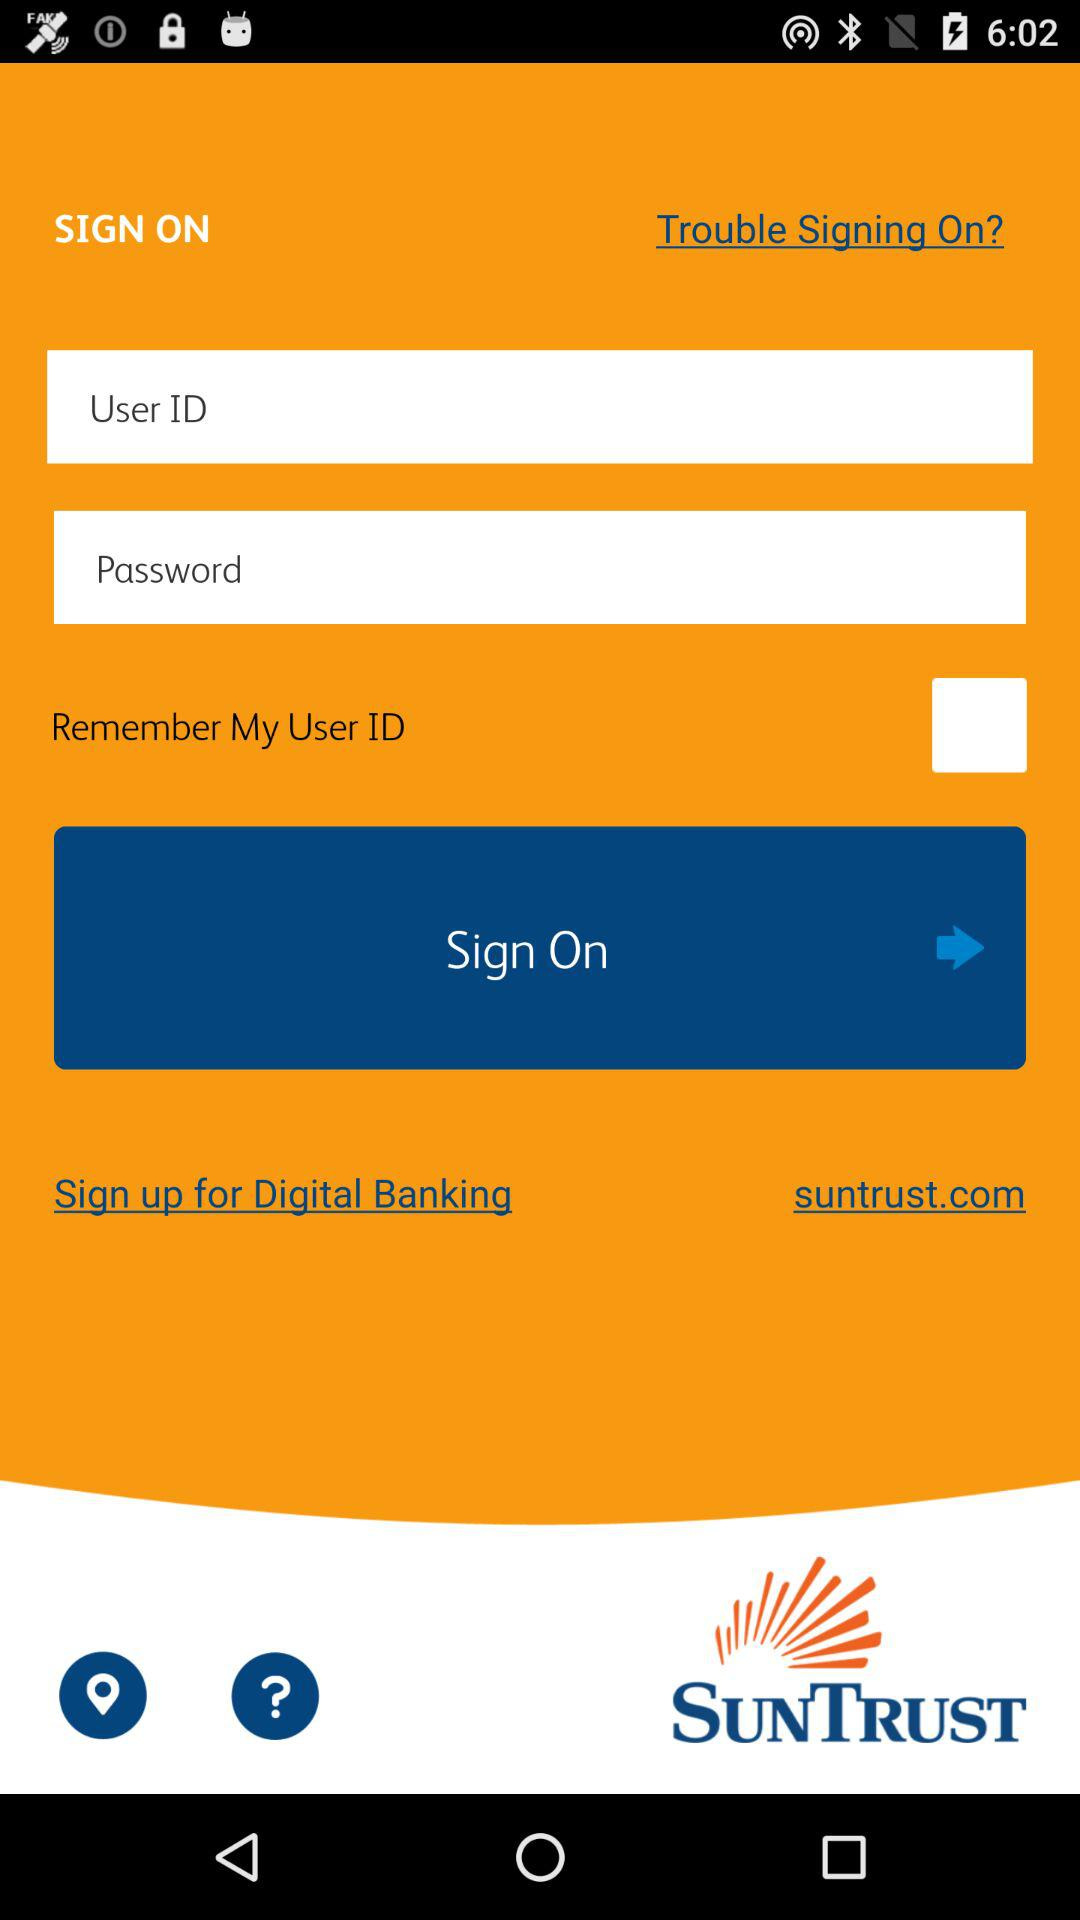What is the app name? The app name is "SUNTRUST". 